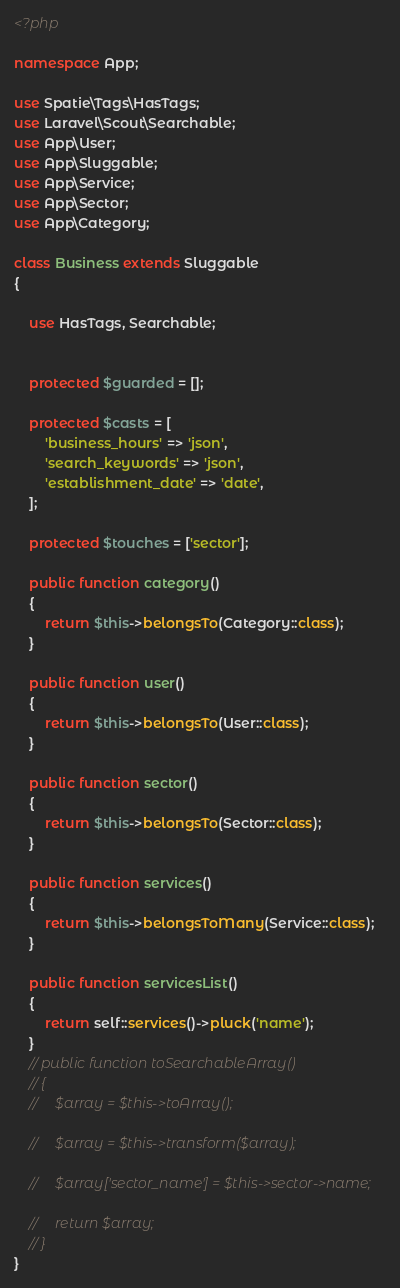<code> <loc_0><loc_0><loc_500><loc_500><_PHP_><?php

namespace App;

use Spatie\Tags\HasTags;
use Laravel\Scout\Searchable;
use App\User;
use App\Sluggable;
use App\Service;
use App\Sector;
use App\Category;

class Business extends Sluggable
{

    use HasTags, Searchable;


    protected $guarded = [];

    protected $casts = [
        'business_hours' => 'json',
        'search_keywords' => 'json',
        'establishment_date' => 'date',
    ];

    protected $touches = ['sector'];

    public function category()
    {
        return $this->belongsTo(Category::class);
    }

    public function user()
    {
        return $this->belongsTo(User::class);
    }

    public function sector()
    {
        return $this->belongsTo(Sector::class);
    }

    public function services()
    {
        return $this->belongsToMany(Service::class);
    }

    public function servicesList()
    {
        return self::services()->pluck('name');
    }
    // public function toSearchableArray()
    // {
    //     $array = $this->toArray();

    //     $array = $this->transform($array);

    //     $array['sector_name'] = $this->sector->name;

    //     return $array;
    // }
}
</code> 